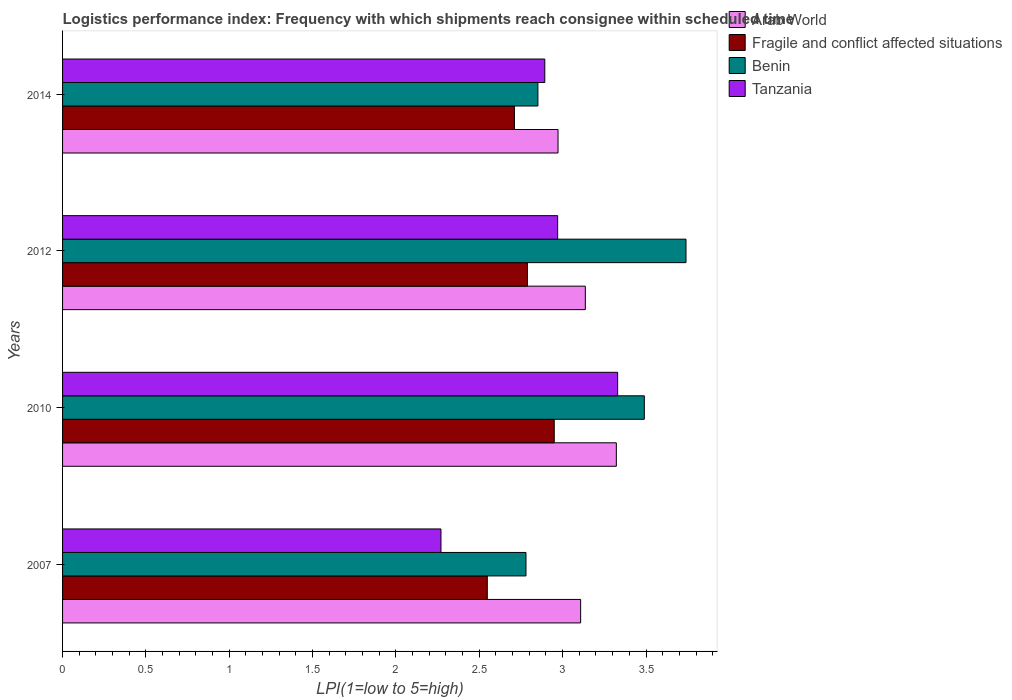How many groups of bars are there?
Keep it short and to the point. 4. Are the number of bars per tick equal to the number of legend labels?
Offer a very short reply. Yes. How many bars are there on the 1st tick from the top?
Offer a very short reply. 4. What is the label of the 2nd group of bars from the top?
Keep it short and to the point. 2012. In how many cases, is the number of bars for a given year not equal to the number of legend labels?
Keep it short and to the point. 0. What is the logistics performance index in Arab World in 2012?
Your response must be concise. 3.14. Across all years, what is the maximum logistics performance index in Fragile and conflict affected situations?
Keep it short and to the point. 2.95. Across all years, what is the minimum logistics performance index in Arab World?
Your answer should be very brief. 2.97. In which year was the logistics performance index in Tanzania maximum?
Offer a terse response. 2010. In which year was the logistics performance index in Fragile and conflict affected situations minimum?
Keep it short and to the point. 2007. What is the total logistics performance index in Benin in the graph?
Your answer should be compact. 12.86. What is the difference between the logistics performance index in Fragile and conflict affected situations in 2012 and that in 2014?
Ensure brevity in your answer.  0.08. What is the difference between the logistics performance index in Arab World in 2014 and the logistics performance index in Fragile and conflict affected situations in 2007?
Your response must be concise. 0.42. What is the average logistics performance index in Tanzania per year?
Ensure brevity in your answer.  2.87. In the year 2014, what is the difference between the logistics performance index in Fragile and conflict affected situations and logistics performance index in Benin?
Keep it short and to the point. -0.14. What is the ratio of the logistics performance index in Benin in 2007 to that in 2012?
Your answer should be very brief. 0.74. What is the difference between the highest and the second highest logistics performance index in Fragile and conflict affected situations?
Offer a terse response. 0.16. What is the difference between the highest and the lowest logistics performance index in Arab World?
Provide a short and direct response. 0.35. Is it the case that in every year, the sum of the logistics performance index in Benin and logistics performance index in Fragile and conflict affected situations is greater than the sum of logistics performance index in Arab World and logistics performance index in Tanzania?
Your answer should be compact. No. What does the 1st bar from the top in 2010 represents?
Ensure brevity in your answer.  Tanzania. What does the 1st bar from the bottom in 2012 represents?
Provide a short and direct response. Arab World. How many bars are there?
Offer a terse response. 16. Are all the bars in the graph horizontal?
Keep it short and to the point. Yes. How many years are there in the graph?
Your answer should be compact. 4. Are the values on the major ticks of X-axis written in scientific E-notation?
Your answer should be very brief. No. How many legend labels are there?
Make the answer very short. 4. What is the title of the graph?
Provide a succinct answer. Logistics performance index: Frequency with which shipments reach consignee within scheduled time. What is the label or title of the X-axis?
Give a very brief answer. LPI(1=low to 5=high). What is the LPI(1=low to 5=high) of Arab World in 2007?
Make the answer very short. 3.11. What is the LPI(1=low to 5=high) of Fragile and conflict affected situations in 2007?
Ensure brevity in your answer.  2.55. What is the LPI(1=low to 5=high) in Benin in 2007?
Provide a succinct answer. 2.78. What is the LPI(1=low to 5=high) of Tanzania in 2007?
Give a very brief answer. 2.27. What is the LPI(1=low to 5=high) in Arab World in 2010?
Keep it short and to the point. 3.32. What is the LPI(1=low to 5=high) in Fragile and conflict affected situations in 2010?
Provide a succinct answer. 2.95. What is the LPI(1=low to 5=high) of Benin in 2010?
Keep it short and to the point. 3.49. What is the LPI(1=low to 5=high) of Tanzania in 2010?
Give a very brief answer. 3.33. What is the LPI(1=low to 5=high) in Arab World in 2012?
Ensure brevity in your answer.  3.14. What is the LPI(1=low to 5=high) of Fragile and conflict affected situations in 2012?
Offer a terse response. 2.79. What is the LPI(1=low to 5=high) in Benin in 2012?
Provide a succinct answer. 3.74. What is the LPI(1=low to 5=high) of Tanzania in 2012?
Keep it short and to the point. 2.97. What is the LPI(1=low to 5=high) of Arab World in 2014?
Offer a very short reply. 2.97. What is the LPI(1=low to 5=high) of Fragile and conflict affected situations in 2014?
Ensure brevity in your answer.  2.71. What is the LPI(1=low to 5=high) of Benin in 2014?
Provide a short and direct response. 2.85. What is the LPI(1=low to 5=high) in Tanzania in 2014?
Offer a very short reply. 2.89. Across all years, what is the maximum LPI(1=low to 5=high) of Arab World?
Keep it short and to the point. 3.32. Across all years, what is the maximum LPI(1=low to 5=high) of Fragile and conflict affected situations?
Make the answer very short. 2.95. Across all years, what is the maximum LPI(1=low to 5=high) of Benin?
Ensure brevity in your answer.  3.74. Across all years, what is the maximum LPI(1=low to 5=high) of Tanzania?
Give a very brief answer. 3.33. Across all years, what is the minimum LPI(1=low to 5=high) in Arab World?
Keep it short and to the point. 2.97. Across all years, what is the minimum LPI(1=low to 5=high) of Fragile and conflict affected situations?
Give a very brief answer. 2.55. Across all years, what is the minimum LPI(1=low to 5=high) in Benin?
Ensure brevity in your answer.  2.78. Across all years, what is the minimum LPI(1=low to 5=high) of Tanzania?
Your response must be concise. 2.27. What is the total LPI(1=low to 5=high) of Arab World in the graph?
Ensure brevity in your answer.  12.54. What is the total LPI(1=low to 5=high) of Fragile and conflict affected situations in the graph?
Ensure brevity in your answer.  11. What is the total LPI(1=low to 5=high) in Benin in the graph?
Give a very brief answer. 12.86. What is the total LPI(1=low to 5=high) of Tanzania in the graph?
Keep it short and to the point. 11.46. What is the difference between the LPI(1=low to 5=high) of Arab World in 2007 and that in 2010?
Offer a terse response. -0.21. What is the difference between the LPI(1=low to 5=high) of Fragile and conflict affected situations in 2007 and that in 2010?
Your answer should be compact. -0.4. What is the difference between the LPI(1=low to 5=high) in Benin in 2007 and that in 2010?
Make the answer very short. -0.71. What is the difference between the LPI(1=low to 5=high) of Tanzania in 2007 and that in 2010?
Give a very brief answer. -1.06. What is the difference between the LPI(1=low to 5=high) of Arab World in 2007 and that in 2012?
Provide a succinct answer. -0.03. What is the difference between the LPI(1=low to 5=high) in Fragile and conflict affected situations in 2007 and that in 2012?
Provide a succinct answer. -0.24. What is the difference between the LPI(1=low to 5=high) of Benin in 2007 and that in 2012?
Your answer should be very brief. -0.96. What is the difference between the LPI(1=low to 5=high) of Arab World in 2007 and that in 2014?
Ensure brevity in your answer.  0.14. What is the difference between the LPI(1=low to 5=high) of Fragile and conflict affected situations in 2007 and that in 2014?
Offer a very short reply. -0.16. What is the difference between the LPI(1=low to 5=high) of Benin in 2007 and that in 2014?
Keep it short and to the point. -0.07. What is the difference between the LPI(1=low to 5=high) of Tanzania in 2007 and that in 2014?
Provide a short and direct response. -0.62. What is the difference between the LPI(1=low to 5=high) in Arab World in 2010 and that in 2012?
Your answer should be compact. 0.19. What is the difference between the LPI(1=low to 5=high) of Fragile and conflict affected situations in 2010 and that in 2012?
Your answer should be compact. 0.16. What is the difference between the LPI(1=low to 5=high) of Benin in 2010 and that in 2012?
Keep it short and to the point. -0.25. What is the difference between the LPI(1=low to 5=high) in Tanzania in 2010 and that in 2012?
Provide a succinct answer. 0.36. What is the difference between the LPI(1=low to 5=high) of Arab World in 2010 and that in 2014?
Offer a very short reply. 0.35. What is the difference between the LPI(1=low to 5=high) of Fragile and conflict affected situations in 2010 and that in 2014?
Give a very brief answer. 0.24. What is the difference between the LPI(1=low to 5=high) of Benin in 2010 and that in 2014?
Your answer should be compact. 0.64. What is the difference between the LPI(1=low to 5=high) in Tanzania in 2010 and that in 2014?
Your response must be concise. 0.44. What is the difference between the LPI(1=low to 5=high) in Arab World in 2012 and that in 2014?
Ensure brevity in your answer.  0.16. What is the difference between the LPI(1=low to 5=high) of Fragile and conflict affected situations in 2012 and that in 2014?
Provide a succinct answer. 0.08. What is the difference between the LPI(1=low to 5=high) of Benin in 2012 and that in 2014?
Provide a succinct answer. 0.89. What is the difference between the LPI(1=low to 5=high) in Tanzania in 2012 and that in 2014?
Provide a succinct answer. 0.08. What is the difference between the LPI(1=low to 5=high) of Arab World in 2007 and the LPI(1=low to 5=high) of Fragile and conflict affected situations in 2010?
Your answer should be very brief. 0.16. What is the difference between the LPI(1=low to 5=high) in Arab World in 2007 and the LPI(1=low to 5=high) in Benin in 2010?
Your response must be concise. -0.38. What is the difference between the LPI(1=low to 5=high) of Arab World in 2007 and the LPI(1=low to 5=high) of Tanzania in 2010?
Your answer should be very brief. -0.22. What is the difference between the LPI(1=low to 5=high) in Fragile and conflict affected situations in 2007 and the LPI(1=low to 5=high) in Benin in 2010?
Keep it short and to the point. -0.94. What is the difference between the LPI(1=low to 5=high) in Fragile and conflict affected situations in 2007 and the LPI(1=low to 5=high) in Tanzania in 2010?
Offer a terse response. -0.78. What is the difference between the LPI(1=low to 5=high) in Benin in 2007 and the LPI(1=low to 5=high) in Tanzania in 2010?
Keep it short and to the point. -0.55. What is the difference between the LPI(1=low to 5=high) in Arab World in 2007 and the LPI(1=low to 5=high) in Fragile and conflict affected situations in 2012?
Provide a succinct answer. 0.32. What is the difference between the LPI(1=low to 5=high) in Arab World in 2007 and the LPI(1=low to 5=high) in Benin in 2012?
Keep it short and to the point. -0.63. What is the difference between the LPI(1=low to 5=high) in Arab World in 2007 and the LPI(1=low to 5=high) in Tanzania in 2012?
Your answer should be very brief. 0.14. What is the difference between the LPI(1=low to 5=high) in Fragile and conflict affected situations in 2007 and the LPI(1=low to 5=high) in Benin in 2012?
Make the answer very short. -1.19. What is the difference between the LPI(1=low to 5=high) of Fragile and conflict affected situations in 2007 and the LPI(1=low to 5=high) of Tanzania in 2012?
Provide a succinct answer. -0.42. What is the difference between the LPI(1=low to 5=high) in Benin in 2007 and the LPI(1=low to 5=high) in Tanzania in 2012?
Your answer should be very brief. -0.19. What is the difference between the LPI(1=low to 5=high) of Arab World in 2007 and the LPI(1=low to 5=high) of Fragile and conflict affected situations in 2014?
Your response must be concise. 0.4. What is the difference between the LPI(1=low to 5=high) of Arab World in 2007 and the LPI(1=low to 5=high) of Benin in 2014?
Keep it short and to the point. 0.26. What is the difference between the LPI(1=low to 5=high) of Arab World in 2007 and the LPI(1=low to 5=high) of Tanzania in 2014?
Provide a succinct answer. 0.21. What is the difference between the LPI(1=low to 5=high) of Fragile and conflict affected situations in 2007 and the LPI(1=low to 5=high) of Benin in 2014?
Provide a succinct answer. -0.3. What is the difference between the LPI(1=low to 5=high) in Fragile and conflict affected situations in 2007 and the LPI(1=low to 5=high) in Tanzania in 2014?
Provide a succinct answer. -0.34. What is the difference between the LPI(1=low to 5=high) in Benin in 2007 and the LPI(1=low to 5=high) in Tanzania in 2014?
Your answer should be very brief. -0.11. What is the difference between the LPI(1=low to 5=high) in Arab World in 2010 and the LPI(1=low to 5=high) in Fragile and conflict affected situations in 2012?
Offer a very short reply. 0.53. What is the difference between the LPI(1=low to 5=high) of Arab World in 2010 and the LPI(1=low to 5=high) of Benin in 2012?
Your answer should be compact. -0.42. What is the difference between the LPI(1=low to 5=high) in Arab World in 2010 and the LPI(1=low to 5=high) in Tanzania in 2012?
Your response must be concise. 0.35. What is the difference between the LPI(1=low to 5=high) in Fragile and conflict affected situations in 2010 and the LPI(1=low to 5=high) in Benin in 2012?
Your response must be concise. -0.79. What is the difference between the LPI(1=low to 5=high) in Fragile and conflict affected situations in 2010 and the LPI(1=low to 5=high) in Tanzania in 2012?
Provide a short and direct response. -0.02. What is the difference between the LPI(1=low to 5=high) of Benin in 2010 and the LPI(1=low to 5=high) of Tanzania in 2012?
Make the answer very short. 0.52. What is the difference between the LPI(1=low to 5=high) in Arab World in 2010 and the LPI(1=low to 5=high) in Fragile and conflict affected situations in 2014?
Provide a short and direct response. 0.61. What is the difference between the LPI(1=low to 5=high) of Arab World in 2010 and the LPI(1=low to 5=high) of Benin in 2014?
Offer a very short reply. 0.47. What is the difference between the LPI(1=low to 5=high) in Arab World in 2010 and the LPI(1=low to 5=high) in Tanzania in 2014?
Ensure brevity in your answer.  0.43. What is the difference between the LPI(1=low to 5=high) of Fragile and conflict affected situations in 2010 and the LPI(1=low to 5=high) of Benin in 2014?
Ensure brevity in your answer.  0.1. What is the difference between the LPI(1=low to 5=high) of Fragile and conflict affected situations in 2010 and the LPI(1=low to 5=high) of Tanzania in 2014?
Your answer should be compact. 0.06. What is the difference between the LPI(1=low to 5=high) in Benin in 2010 and the LPI(1=low to 5=high) in Tanzania in 2014?
Keep it short and to the point. 0.6. What is the difference between the LPI(1=low to 5=high) in Arab World in 2012 and the LPI(1=low to 5=high) in Fragile and conflict affected situations in 2014?
Provide a succinct answer. 0.43. What is the difference between the LPI(1=low to 5=high) in Arab World in 2012 and the LPI(1=low to 5=high) in Benin in 2014?
Give a very brief answer. 0.28. What is the difference between the LPI(1=low to 5=high) of Arab World in 2012 and the LPI(1=low to 5=high) of Tanzania in 2014?
Give a very brief answer. 0.24. What is the difference between the LPI(1=low to 5=high) of Fragile and conflict affected situations in 2012 and the LPI(1=low to 5=high) of Benin in 2014?
Make the answer very short. -0.06. What is the difference between the LPI(1=low to 5=high) in Fragile and conflict affected situations in 2012 and the LPI(1=low to 5=high) in Tanzania in 2014?
Offer a very short reply. -0.1. What is the difference between the LPI(1=low to 5=high) of Benin in 2012 and the LPI(1=low to 5=high) of Tanzania in 2014?
Your answer should be compact. 0.85. What is the average LPI(1=low to 5=high) in Arab World per year?
Offer a terse response. 3.13. What is the average LPI(1=low to 5=high) of Fragile and conflict affected situations per year?
Offer a terse response. 2.75. What is the average LPI(1=low to 5=high) in Benin per year?
Offer a very short reply. 3.22. What is the average LPI(1=low to 5=high) in Tanzania per year?
Provide a succinct answer. 2.87. In the year 2007, what is the difference between the LPI(1=low to 5=high) in Arab World and LPI(1=low to 5=high) in Fragile and conflict affected situations?
Ensure brevity in your answer.  0.56. In the year 2007, what is the difference between the LPI(1=low to 5=high) in Arab World and LPI(1=low to 5=high) in Benin?
Ensure brevity in your answer.  0.33. In the year 2007, what is the difference between the LPI(1=low to 5=high) in Arab World and LPI(1=low to 5=high) in Tanzania?
Keep it short and to the point. 0.84. In the year 2007, what is the difference between the LPI(1=low to 5=high) in Fragile and conflict affected situations and LPI(1=low to 5=high) in Benin?
Ensure brevity in your answer.  -0.23. In the year 2007, what is the difference between the LPI(1=low to 5=high) in Fragile and conflict affected situations and LPI(1=low to 5=high) in Tanzania?
Keep it short and to the point. 0.28. In the year 2007, what is the difference between the LPI(1=low to 5=high) of Benin and LPI(1=low to 5=high) of Tanzania?
Provide a short and direct response. 0.51. In the year 2010, what is the difference between the LPI(1=low to 5=high) in Arab World and LPI(1=low to 5=high) in Fragile and conflict affected situations?
Ensure brevity in your answer.  0.37. In the year 2010, what is the difference between the LPI(1=low to 5=high) in Arab World and LPI(1=low to 5=high) in Benin?
Provide a succinct answer. -0.17. In the year 2010, what is the difference between the LPI(1=low to 5=high) in Arab World and LPI(1=low to 5=high) in Tanzania?
Make the answer very short. -0.01. In the year 2010, what is the difference between the LPI(1=low to 5=high) of Fragile and conflict affected situations and LPI(1=low to 5=high) of Benin?
Offer a terse response. -0.54. In the year 2010, what is the difference between the LPI(1=low to 5=high) in Fragile and conflict affected situations and LPI(1=low to 5=high) in Tanzania?
Your answer should be very brief. -0.38. In the year 2010, what is the difference between the LPI(1=low to 5=high) of Benin and LPI(1=low to 5=high) of Tanzania?
Ensure brevity in your answer.  0.16. In the year 2012, what is the difference between the LPI(1=low to 5=high) in Arab World and LPI(1=low to 5=high) in Fragile and conflict affected situations?
Offer a very short reply. 0.35. In the year 2012, what is the difference between the LPI(1=low to 5=high) in Arab World and LPI(1=low to 5=high) in Benin?
Provide a succinct answer. -0.6. In the year 2012, what is the difference between the LPI(1=low to 5=high) of Arab World and LPI(1=low to 5=high) of Tanzania?
Provide a succinct answer. 0.17. In the year 2012, what is the difference between the LPI(1=low to 5=high) in Fragile and conflict affected situations and LPI(1=low to 5=high) in Benin?
Your answer should be very brief. -0.95. In the year 2012, what is the difference between the LPI(1=low to 5=high) of Fragile and conflict affected situations and LPI(1=low to 5=high) of Tanzania?
Your response must be concise. -0.18. In the year 2012, what is the difference between the LPI(1=low to 5=high) of Benin and LPI(1=low to 5=high) of Tanzania?
Your answer should be very brief. 0.77. In the year 2014, what is the difference between the LPI(1=low to 5=high) in Arab World and LPI(1=low to 5=high) in Fragile and conflict affected situations?
Your answer should be very brief. 0.26. In the year 2014, what is the difference between the LPI(1=low to 5=high) in Arab World and LPI(1=low to 5=high) in Benin?
Keep it short and to the point. 0.12. In the year 2014, what is the difference between the LPI(1=low to 5=high) of Arab World and LPI(1=low to 5=high) of Tanzania?
Make the answer very short. 0.08. In the year 2014, what is the difference between the LPI(1=low to 5=high) of Fragile and conflict affected situations and LPI(1=low to 5=high) of Benin?
Ensure brevity in your answer.  -0.14. In the year 2014, what is the difference between the LPI(1=low to 5=high) in Fragile and conflict affected situations and LPI(1=low to 5=high) in Tanzania?
Make the answer very short. -0.18. In the year 2014, what is the difference between the LPI(1=low to 5=high) in Benin and LPI(1=low to 5=high) in Tanzania?
Your response must be concise. -0.04. What is the ratio of the LPI(1=low to 5=high) in Arab World in 2007 to that in 2010?
Offer a very short reply. 0.94. What is the ratio of the LPI(1=low to 5=high) of Fragile and conflict affected situations in 2007 to that in 2010?
Your response must be concise. 0.86. What is the ratio of the LPI(1=low to 5=high) of Benin in 2007 to that in 2010?
Provide a succinct answer. 0.8. What is the ratio of the LPI(1=low to 5=high) of Tanzania in 2007 to that in 2010?
Offer a very short reply. 0.68. What is the ratio of the LPI(1=low to 5=high) of Fragile and conflict affected situations in 2007 to that in 2012?
Provide a succinct answer. 0.91. What is the ratio of the LPI(1=low to 5=high) of Benin in 2007 to that in 2012?
Your answer should be very brief. 0.74. What is the ratio of the LPI(1=low to 5=high) in Tanzania in 2007 to that in 2012?
Provide a short and direct response. 0.76. What is the ratio of the LPI(1=low to 5=high) of Arab World in 2007 to that in 2014?
Your answer should be compact. 1.05. What is the ratio of the LPI(1=low to 5=high) in Fragile and conflict affected situations in 2007 to that in 2014?
Provide a short and direct response. 0.94. What is the ratio of the LPI(1=low to 5=high) of Benin in 2007 to that in 2014?
Make the answer very short. 0.97. What is the ratio of the LPI(1=low to 5=high) of Tanzania in 2007 to that in 2014?
Offer a very short reply. 0.78. What is the ratio of the LPI(1=low to 5=high) in Arab World in 2010 to that in 2012?
Your answer should be very brief. 1.06. What is the ratio of the LPI(1=low to 5=high) in Fragile and conflict affected situations in 2010 to that in 2012?
Offer a terse response. 1.06. What is the ratio of the LPI(1=low to 5=high) of Benin in 2010 to that in 2012?
Make the answer very short. 0.93. What is the ratio of the LPI(1=low to 5=high) of Tanzania in 2010 to that in 2012?
Provide a succinct answer. 1.12. What is the ratio of the LPI(1=low to 5=high) in Arab World in 2010 to that in 2014?
Offer a very short reply. 1.12. What is the ratio of the LPI(1=low to 5=high) of Fragile and conflict affected situations in 2010 to that in 2014?
Give a very brief answer. 1.09. What is the ratio of the LPI(1=low to 5=high) in Benin in 2010 to that in 2014?
Your answer should be very brief. 1.22. What is the ratio of the LPI(1=low to 5=high) of Tanzania in 2010 to that in 2014?
Provide a succinct answer. 1.15. What is the ratio of the LPI(1=low to 5=high) in Arab World in 2012 to that in 2014?
Ensure brevity in your answer.  1.06. What is the ratio of the LPI(1=low to 5=high) of Fragile and conflict affected situations in 2012 to that in 2014?
Your answer should be compact. 1.03. What is the ratio of the LPI(1=low to 5=high) in Benin in 2012 to that in 2014?
Ensure brevity in your answer.  1.31. What is the ratio of the LPI(1=low to 5=high) of Tanzania in 2012 to that in 2014?
Make the answer very short. 1.03. What is the difference between the highest and the second highest LPI(1=low to 5=high) of Arab World?
Keep it short and to the point. 0.19. What is the difference between the highest and the second highest LPI(1=low to 5=high) of Fragile and conflict affected situations?
Offer a terse response. 0.16. What is the difference between the highest and the second highest LPI(1=low to 5=high) of Benin?
Provide a succinct answer. 0.25. What is the difference between the highest and the second highest LPI(1=low to 5=high) of Tanzania?
Ensure brevity in your answer.  0.36. What is the difference between the highest and the lowest LPI(1=low to 5=high) of Arab World?
Give a very brief answer. 0.35. What is the difference between the highest and the lowest LPI(1=low to 5=high) of Fragile and conflict affected situations?
Give a very brief answer. 0.4. What is the difference between the highest and the lowest LPI(1=low to 5=high) of Benin?
Offer a very short reply. 0.96. What is the difference between the highest and the lowest LPI(1=low to 5=high) of Tanzania?
Provide a short and direct response. 1.06. 